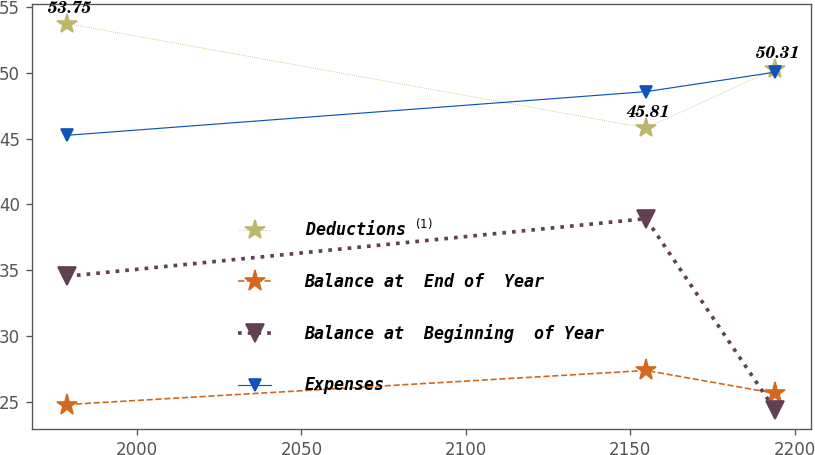Convert chart. <chart><loc_0><loc_0><loc_500><loc_500><line_chart><ecel><fcel>Deductions $^{(1)}$<fcel>Balance at  End of  Year<fcel>Balance at  Beginning  of Year<fcel>Expenses<nl><fcel>1978.84<fcel>53.75<fcel>24.78<fcel>34.54<fcel>45.26<nl><fcel>2154.8<fcel>45.81<fcel>27.37<fcel>38.92<fcel>48.58<nl><fcel>2194.03<fcel>50.31<fcel>25.63<fcel>24.36<fcel>50.06<nl></chart> 